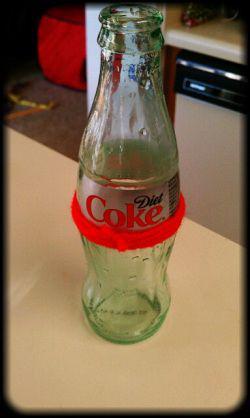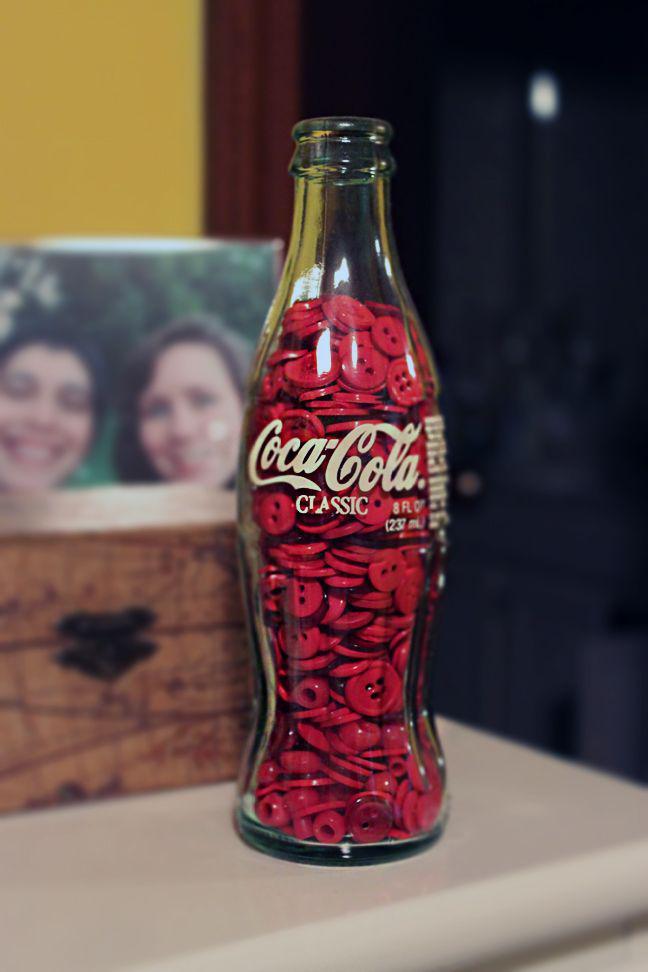The first image is the image on the left, the second image is the image on the right. For the images shown, is this caption "One image contains several evenly spaced glass soda bottles with white lettering on red labels." true? Answer yes or no. No. The first image is the image on the left, the second image is the image on the right. Assess this claim about the two images: "There are exactly two bottles.". Correct or not? Answer yes or no. Yes. 